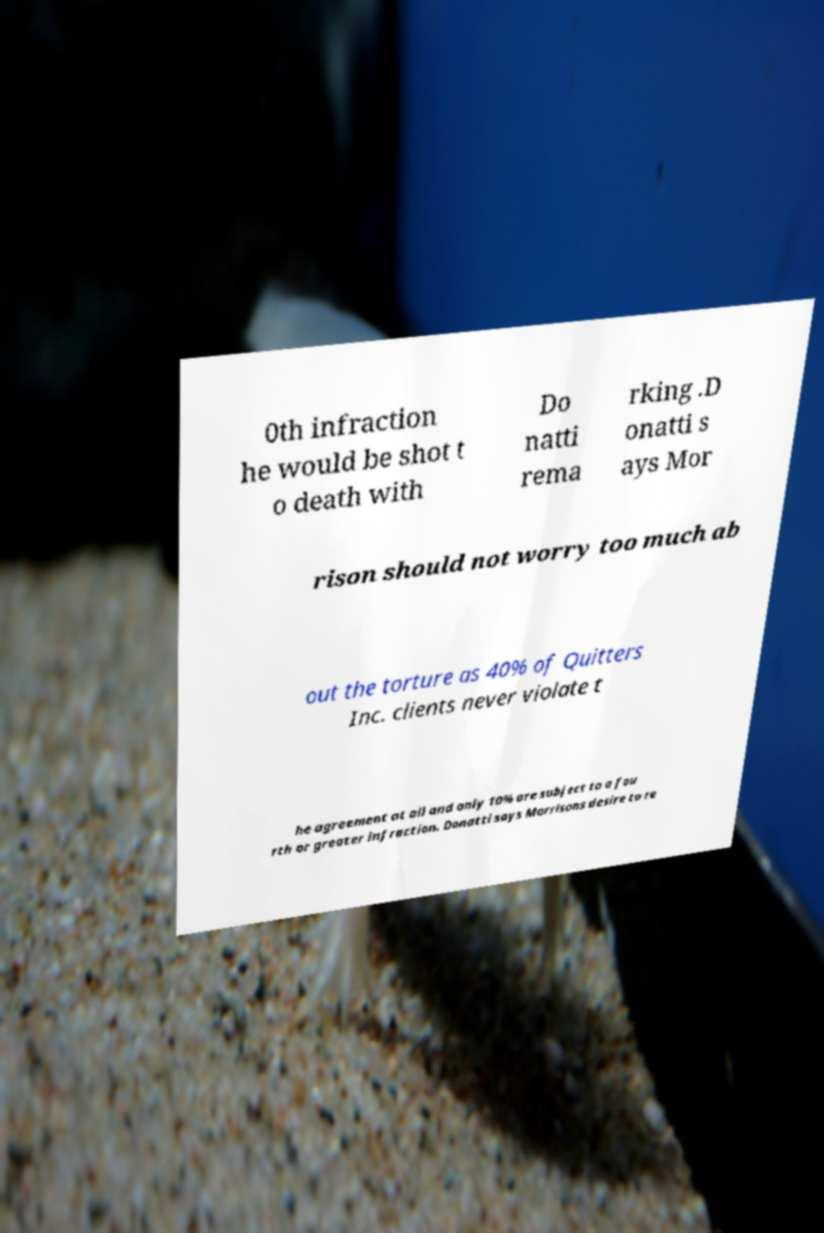Please identify and transcribe the text found in this image. 0th infraction he would be shot t o death with Do natti rema rking .D onatti s ays Mor rison should not worry too much ab out the torture as 40% of Quitters Inc. clients never violate t he agreement at all and only 10% are subject to a fou rth or greater infraction. Donatti says Morrisons desire to re 